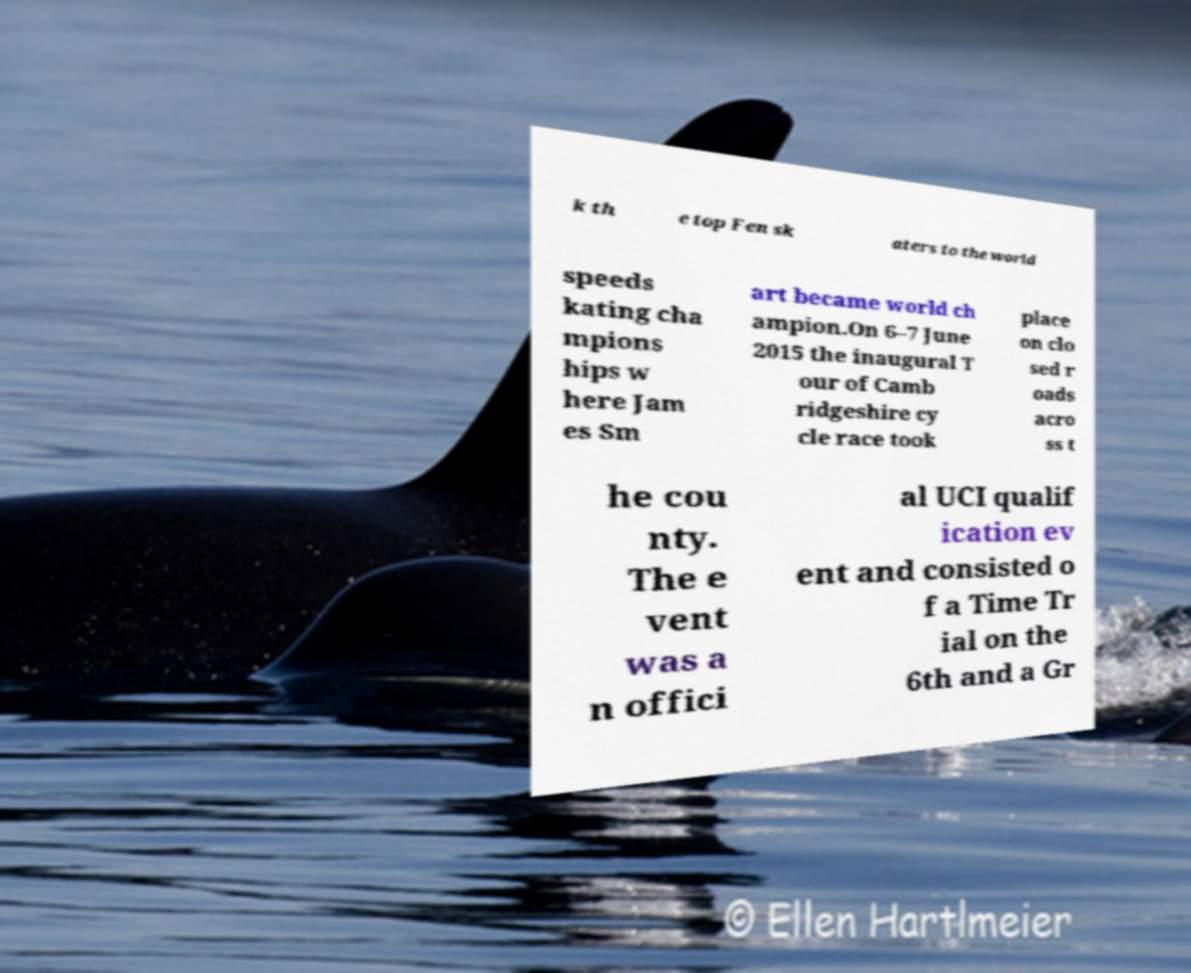Could you extract and type out the text from this image? k th e top Fen sk aters to the world speeds kating cha mpions hips w here Jam es Sm art became world ch ampion.On 6–7 June 2015 the inaugural T our of Camb ridgeshire cy cle race took place on clo sed r oads acro ss t he cou nty. The e vent was a n offici al UCI qualif ication ev ent and consisted o f a Time Tr ial on the 6th and a Gr 